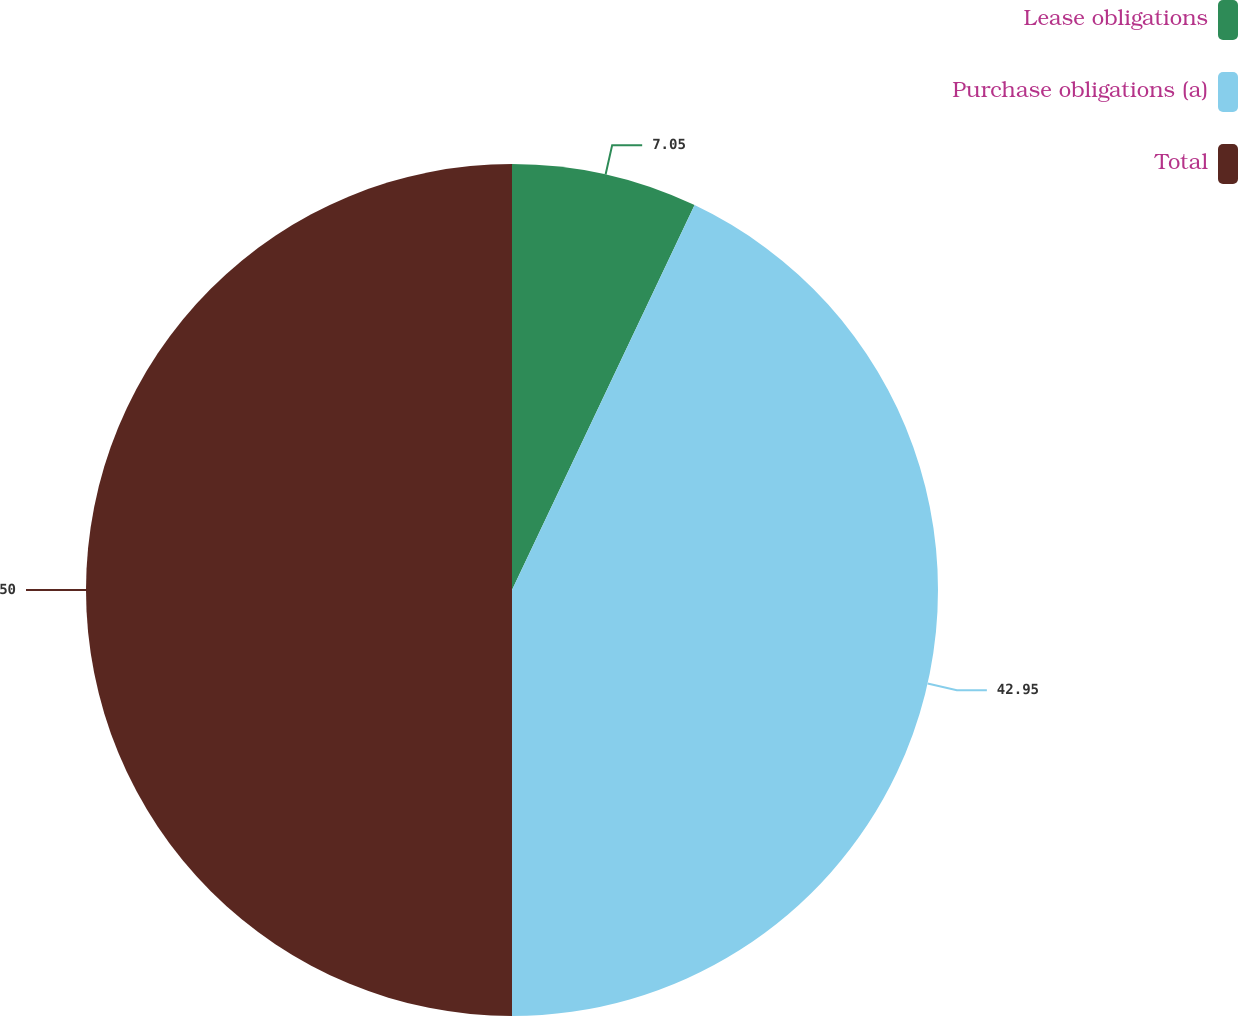Convert chart to OTSL. <chart><loc_0><loc_0><loc_500><loc_500><pie_chart><fcel>Lease obligations<fcel>Purchase obligations (a)<fcel>Total<nl><fcel>7.05%<fcel>42.95%<fcel>50.0%<nl></chart> 